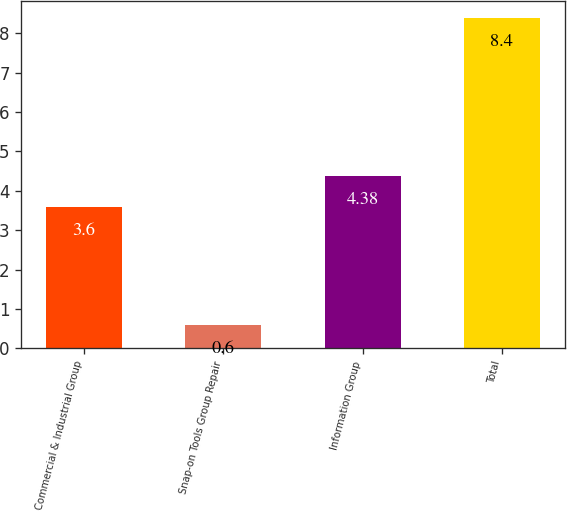Convert chart. <chart><loc_0><loc_0><loc_500><loc_500><bar_chart><fcel>Commercial & Industrial Group<fcel>Snap-on Tools Group Repair<fcel>Information Group<fcel>Total<nl><fcel>3.6<fcel>0.6<fcel>4.38<fcel>8.4<nl></chart> 